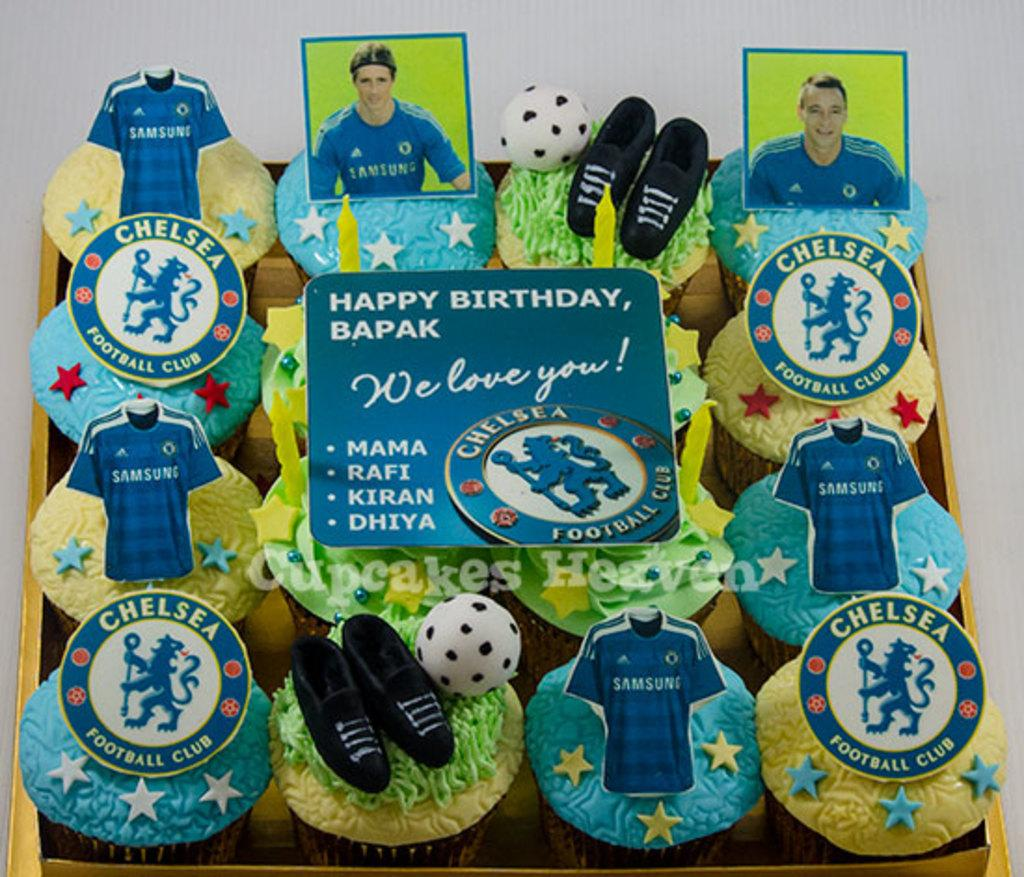What sports team is featured in the image? Chelsea fc is present in the image. What type of gate is visible in the image? There is no gate present in the image; it only features Chelsea fc. What color is the vest worn by the Chelsea fc players in the image? The image does not show any players or their vests, so we cannot determine the color of any vests. 